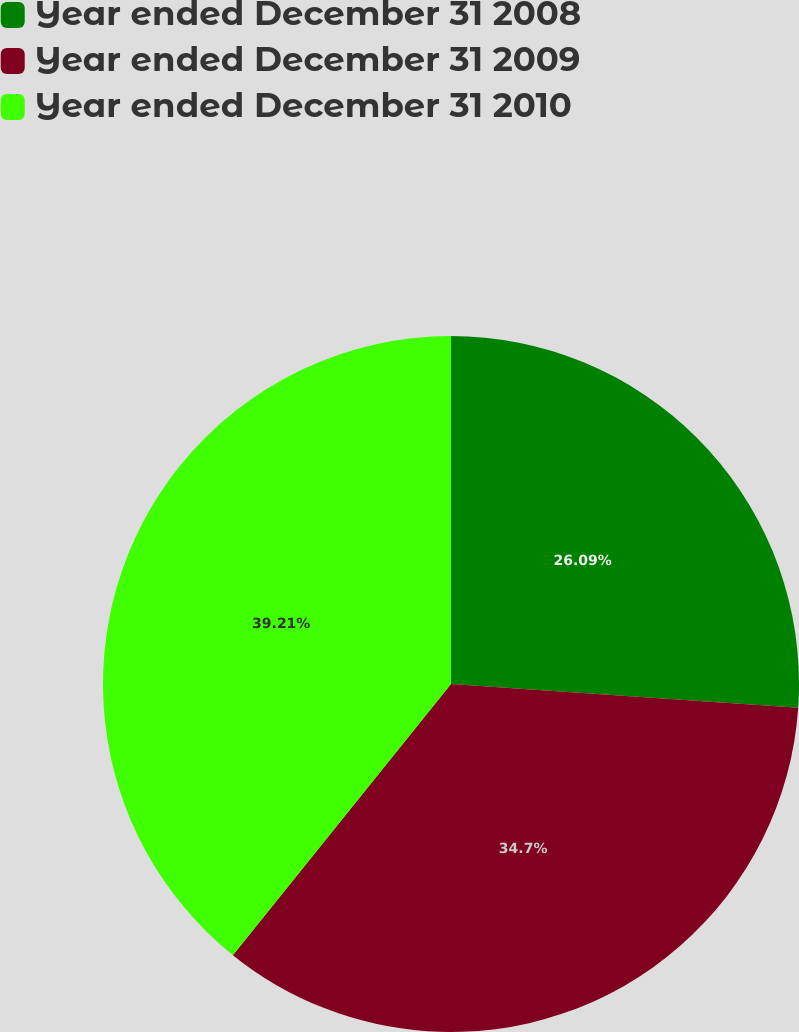Convert chart to OTSL. <chart><loc_0><loc_0><loc_500><loc_500><pie_chart><fcel>Year ended December 31 2008<fcel>Year ended December 31 2009<fcel>Year ended December 31 2010<nl><fcel>26.09%<fcel>34.7%<fcel>39.22%<nl></chart> 